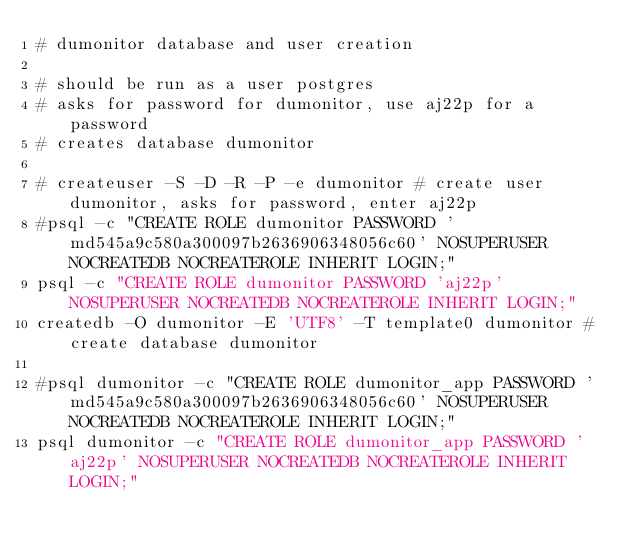<code> <loc_0><loc_0><loc_500><loc_500><_Bash_># dumonitor database and user creation

# should be run as a user postgres
# asks for password for dumonitor, use aj22p for a password
# creates database dumonitor

# createuser -S -D -R -P -e dumonitor # create user dumonitor, asks for password, enter aj22p
#psql -c "CREATE ROLE dumonitor PASSWORD 'md545a9c580a300097b2636906348056c60' NOSUPERUSER NOCREATEDB NOCREATEROLE INHERIT LOGIN;"
psql -c "CREATE ROLE dumonitor PASSWORD 'aj22p' NOSUPERUSER NOCREATEDB NOCREATEROLE INHERIT LOGIN;"
createdb -O dumonitor -E 'UTF8' -T template0 dumonitor # create database dumonitor

#psql dumonitor -c "CREATE ROLE dumonitor_app PASSWORD 'md545a9c580a300097b2636906348056c60' NOSUPERUSER NOCREATEDB NOCREATEROLE INHERIT LOGIN;"
psql dumonitor -c "CREATE ROLE dumonitor_app PASSWORD 'aj22p' NOSUPERUSER NOCREATEDB NOCREATEROLE INHERIT LOGIN;"
</code> 